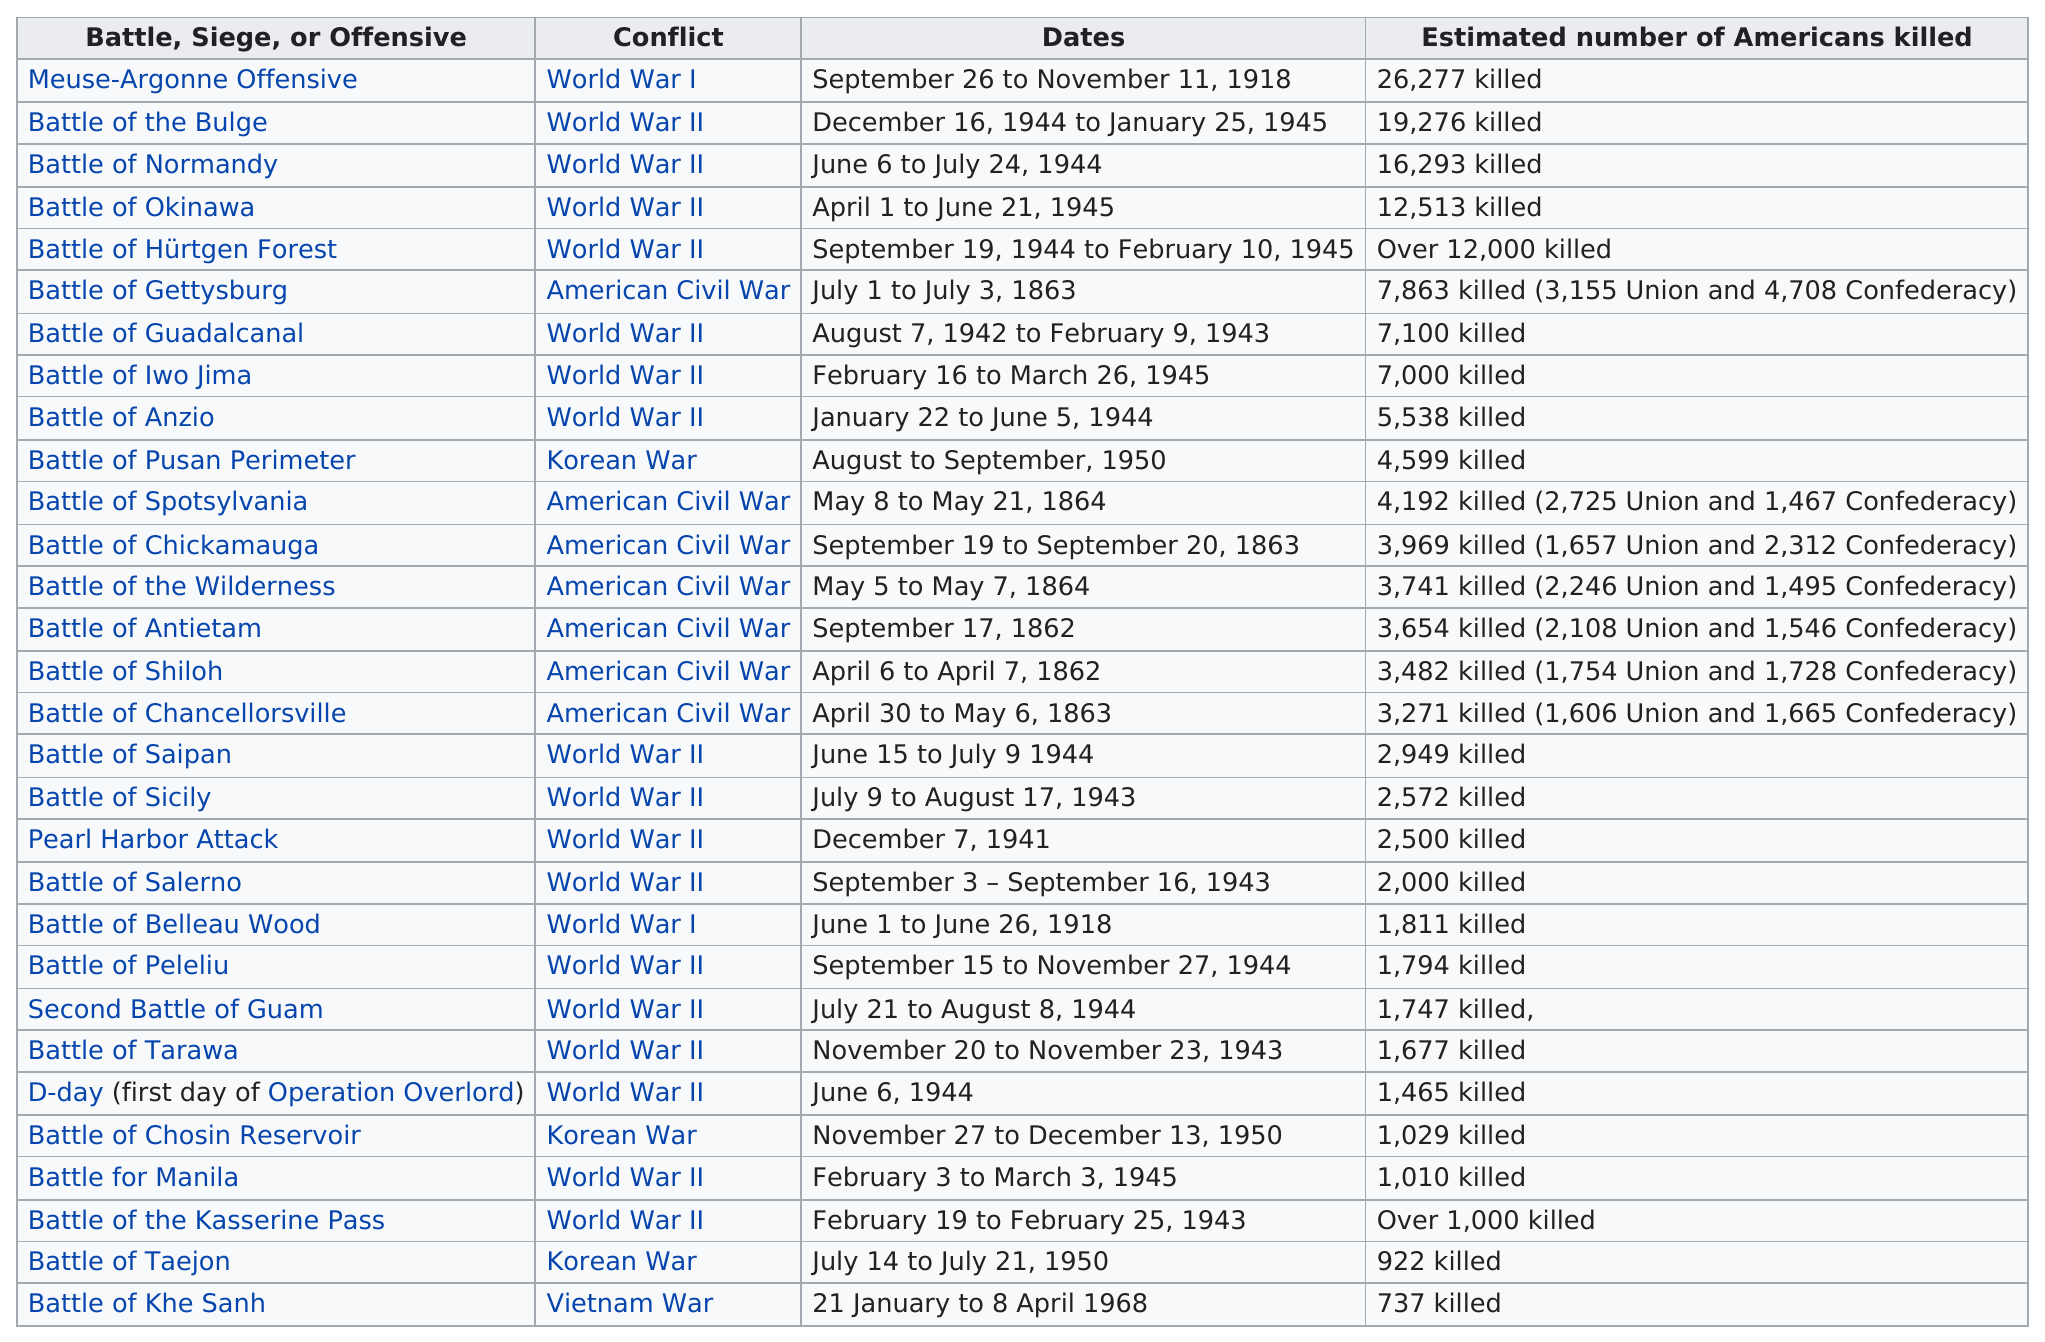Point out several critical features in this image. An estimated 3,000 to 4,200 Americans were killed in battles. 